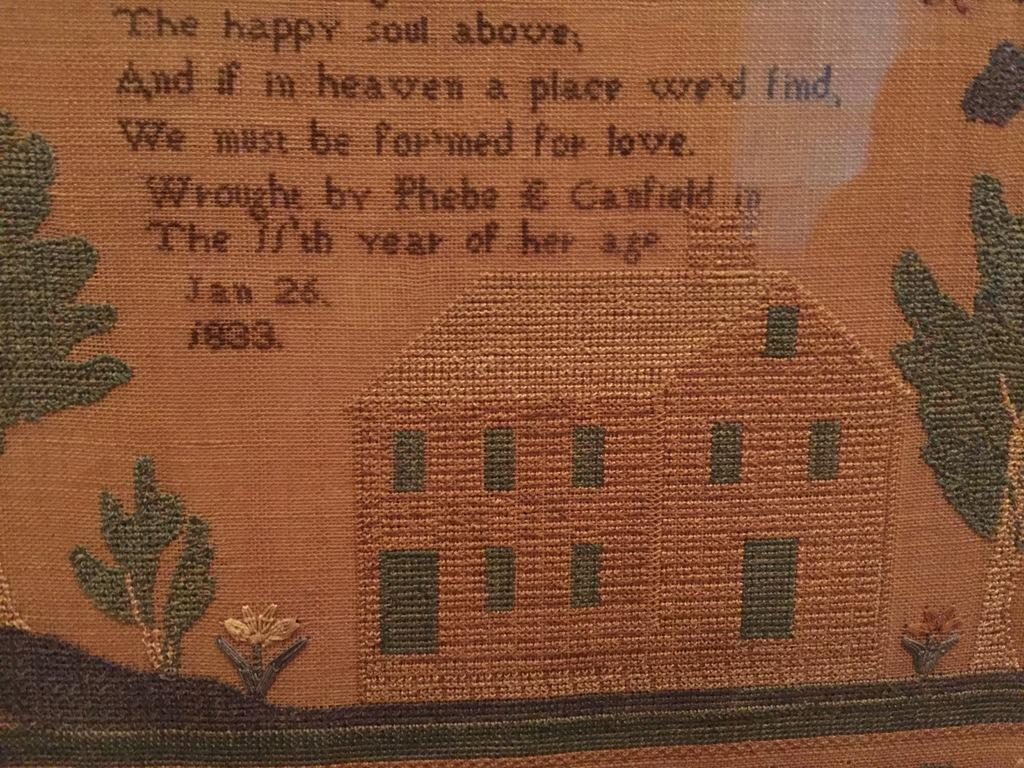What type of material is the main subject of the image? The image appears to be a cloth. What is depicted on the cloth? There is a house and plants shown on the cloth. Where is the text located on the cloth? The text is at the top of the cloth. Can you tell me how the plants on the cloth are stretching towards the sun? There is no indication of the plants stretching towards the sun in the image, as it is a depiction on a cloth and not a live scene. 